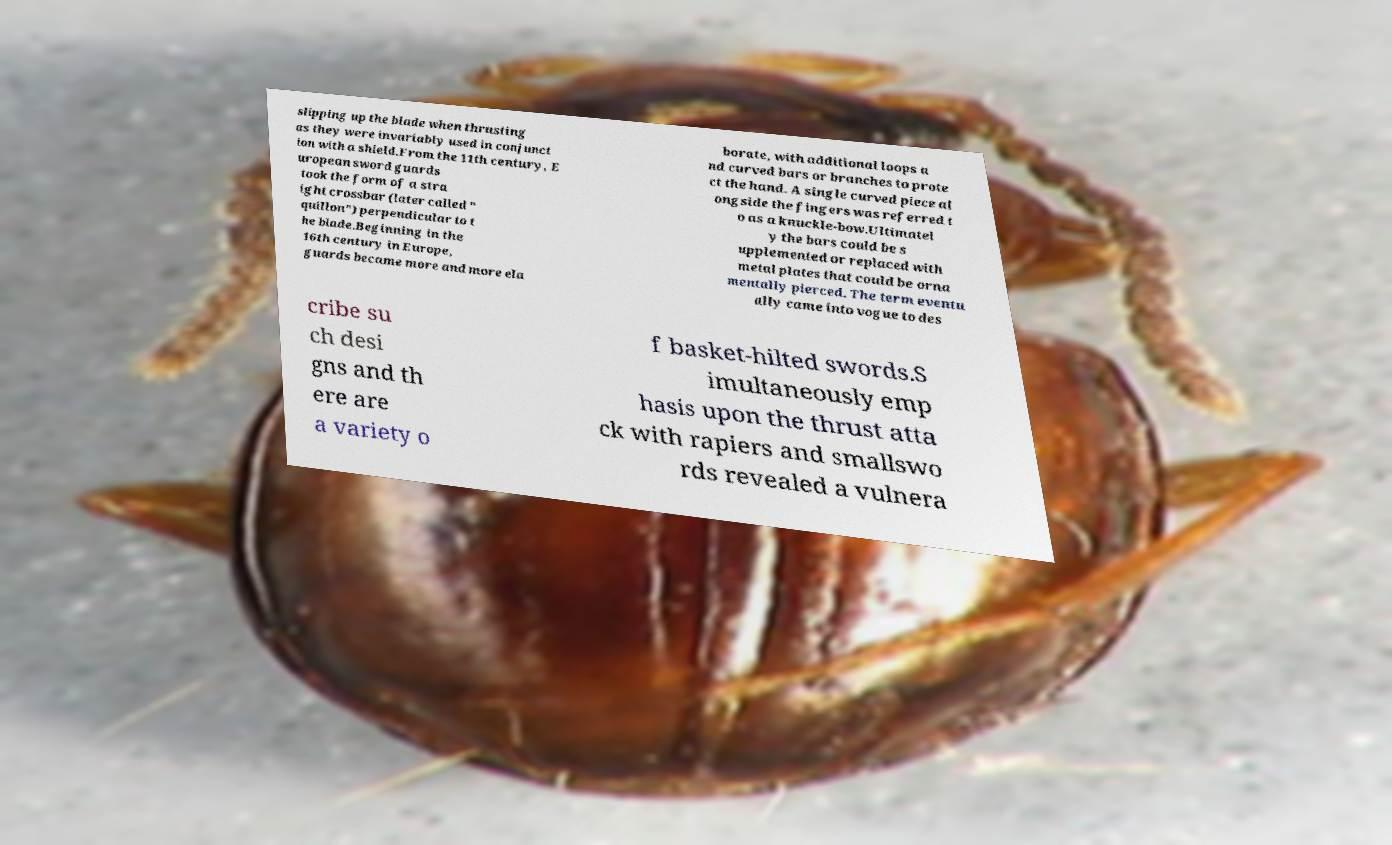For documentation purposes, I need the text within this image transcribed. Could you provide that? slipping up the blade when thrusting as they were invariably used in conjunct ion with a shield.From the 11th century, E uropean sword guards took the form of a stra ight crossbar (later called " quillon") perpendicular to t he blade.Beginning in the 16th century in Europe, guards became more and more ela borate, with additional loops a nd curved bars or branches to prote ct the hand. A single curved piece al ongside the fingers was referred t o as a knuckle-bow.Ultimatel y the bars could be s upplemented or replaced with metal plates that could be orna mentally pierced. The term eventu ally came into vogue to des cribe su ch desi gns and th ere are a variety o f basket-hilted swords.S imultaneously emp hasis upon the thrust atta ck with rapiers and smallswo rds revealed a vulnera 